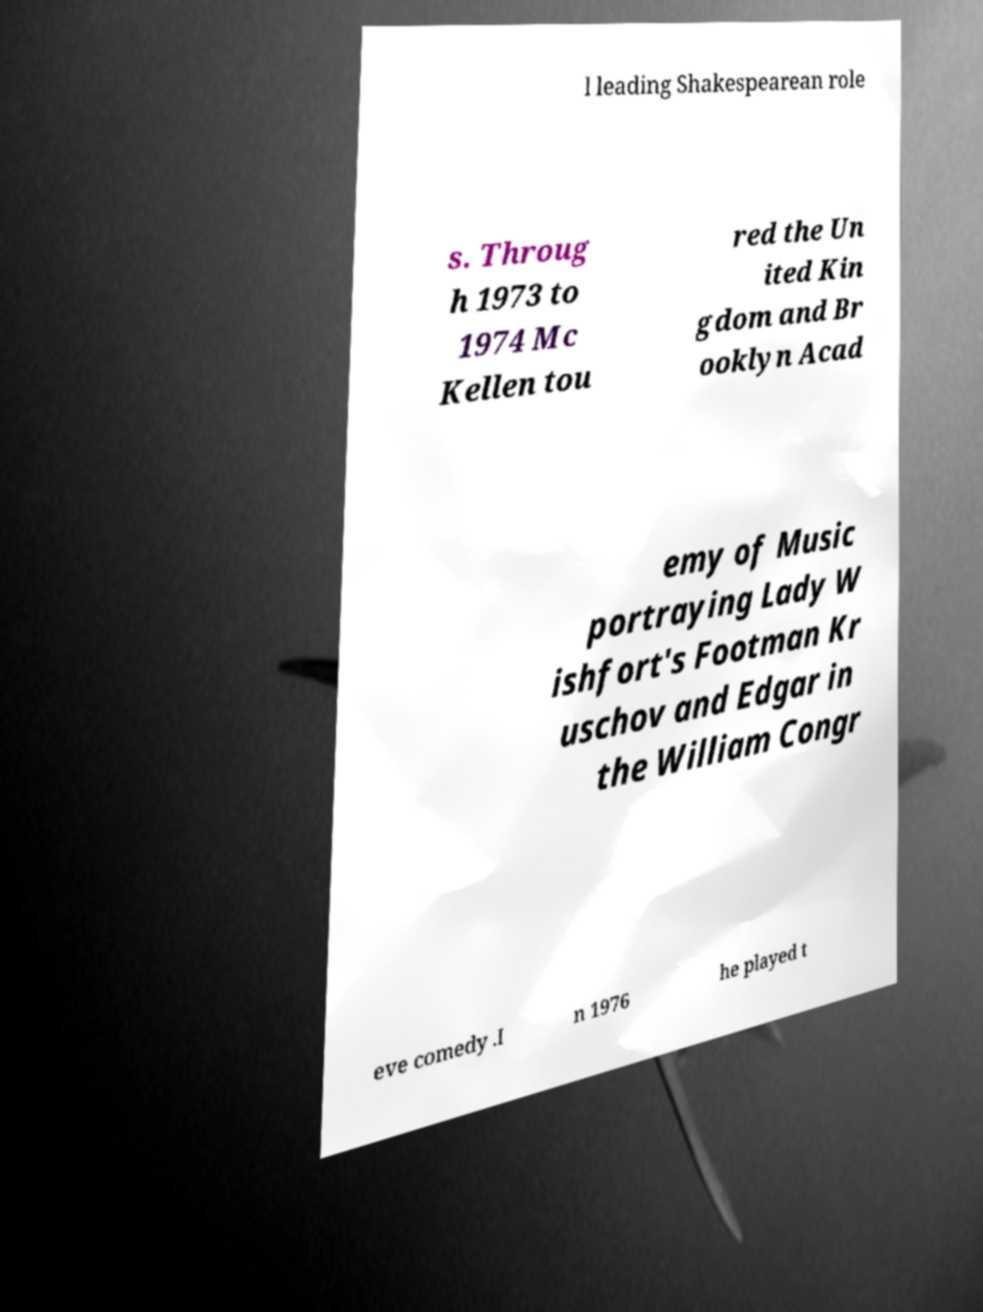There's text embedded in this image that I need extracted. Can you transcribe it verbatim? l leading Shakespearean role s. Throug h 1973 to 1974 Mc Kellen tou red the Un ited Kin gdom and Br ooklyn Acad emy of Music portraying Lady W ishfort's Footman Kr uschov and Edgar in the William Congr eve comedy .I n 1976 he played t 